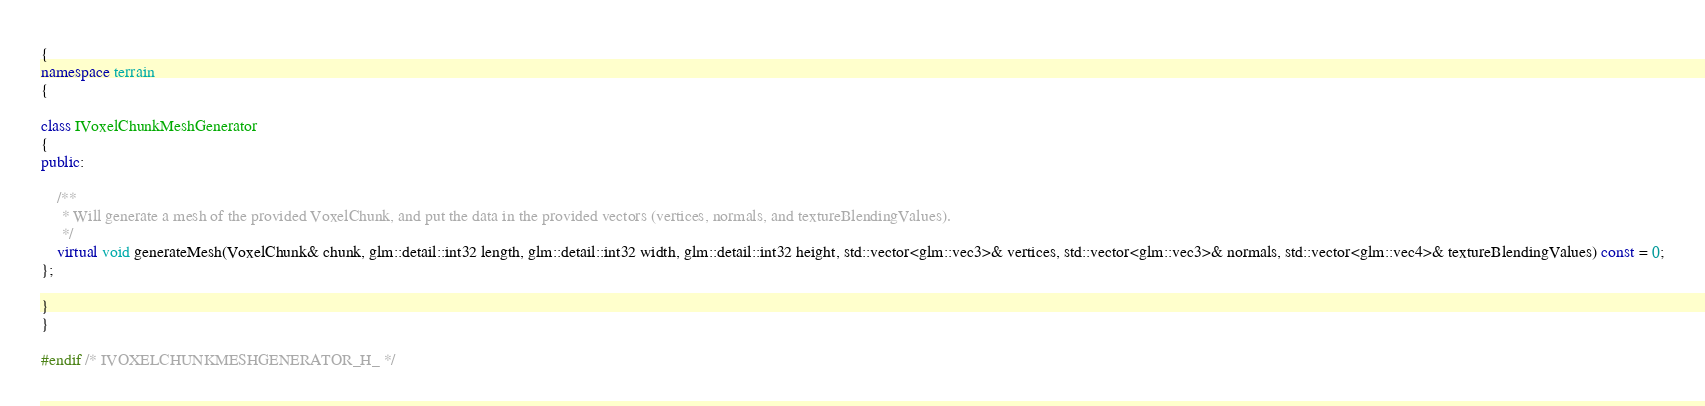Convert code to text. <code><loc_0><loc_0><loc_500><loc_500><_C++_>{
namespace terrain
{

class IVoxelChunkMeshGenerator
{
public:

	/**
	 * Will generate a mesh of the provided VoxelChunk, and put the data in the provided vectors (vertices, normals, and textureBlendingValues).
	 */
	virtual void generateMesh(VoxelChunk& chunk, glm::detail::int32 length, glm::detail::int32 width, glm::detail::int32 height, std::vector<glm::vec3>& vertices, std::vector<glm::vec3>& normals, std::vector<glm::vec4>& textureBlendingValues) const = 0;
};

}
}

#endif /* IVOXELCHUNKMESHGENERATOR_H_ */
</code> 